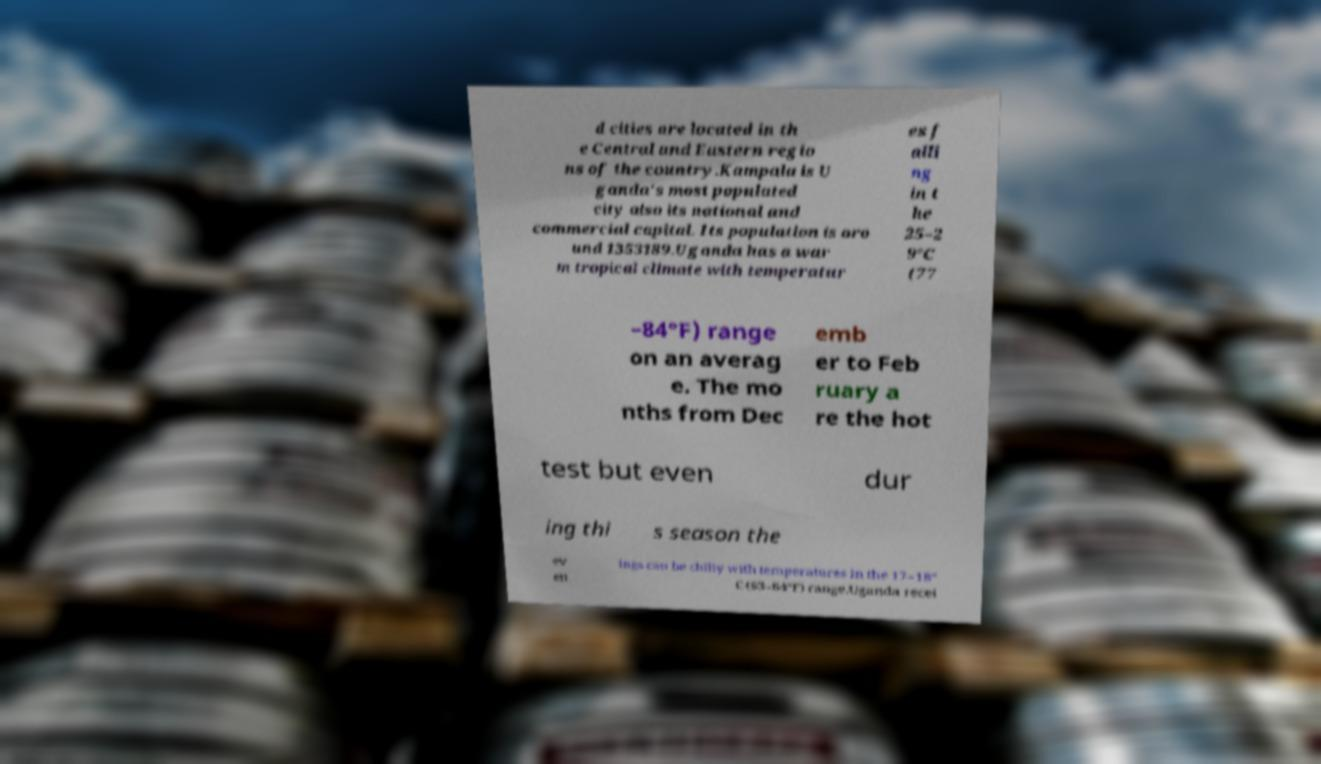I need the written content from this picture converted into text. Can you do that? d cities are located in th e Central and Eastern regio ns of the country.Kampala is U ganda's most populated city also its national and commercial capital. Its population is aro und 1353189.Uganda has a war m tropical climate with temperatur es f alli ng in t he 25–2 9°C (77 –84°F) range on an averag e. The mo nths from Dec emb er to Feb ruary a re the hot test but even dur ing thi s season the ev en ings can be chilly with temperatures in the 17–18° C (63–64°F) range.Uganda recei 